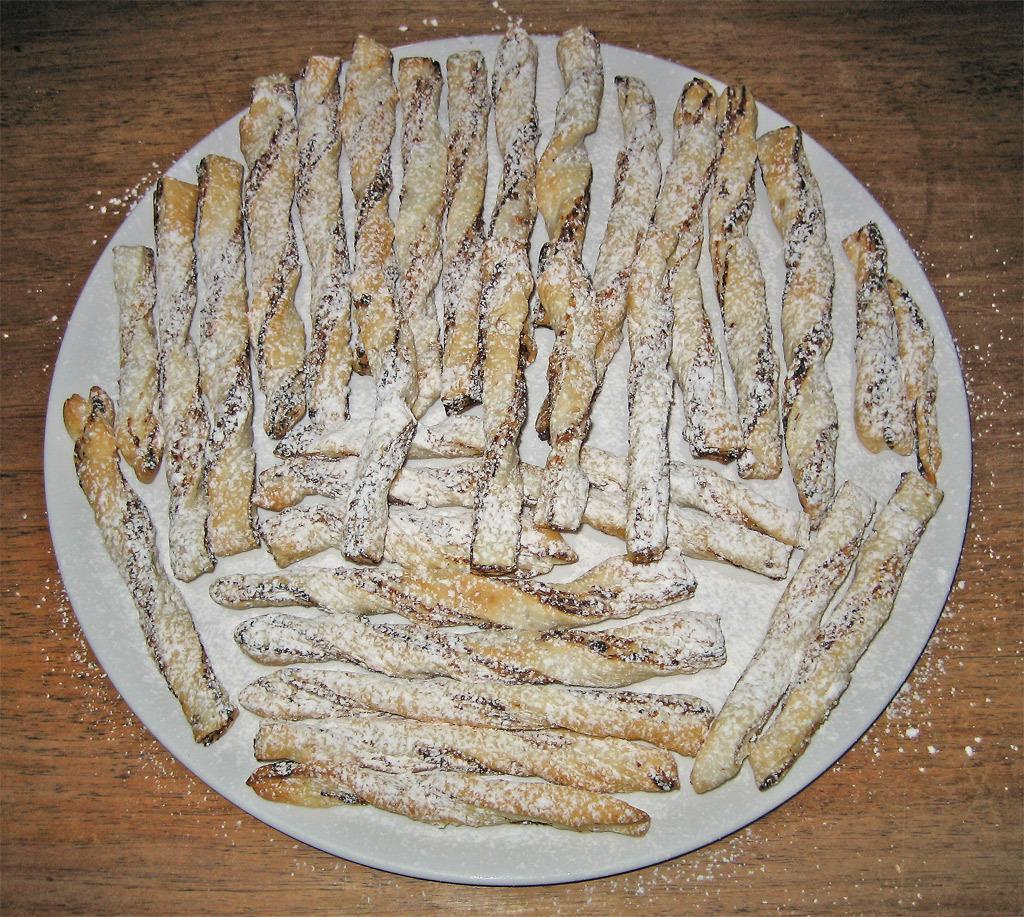Describe this image in one or two sentences. This image consist of food which is on the plate. 